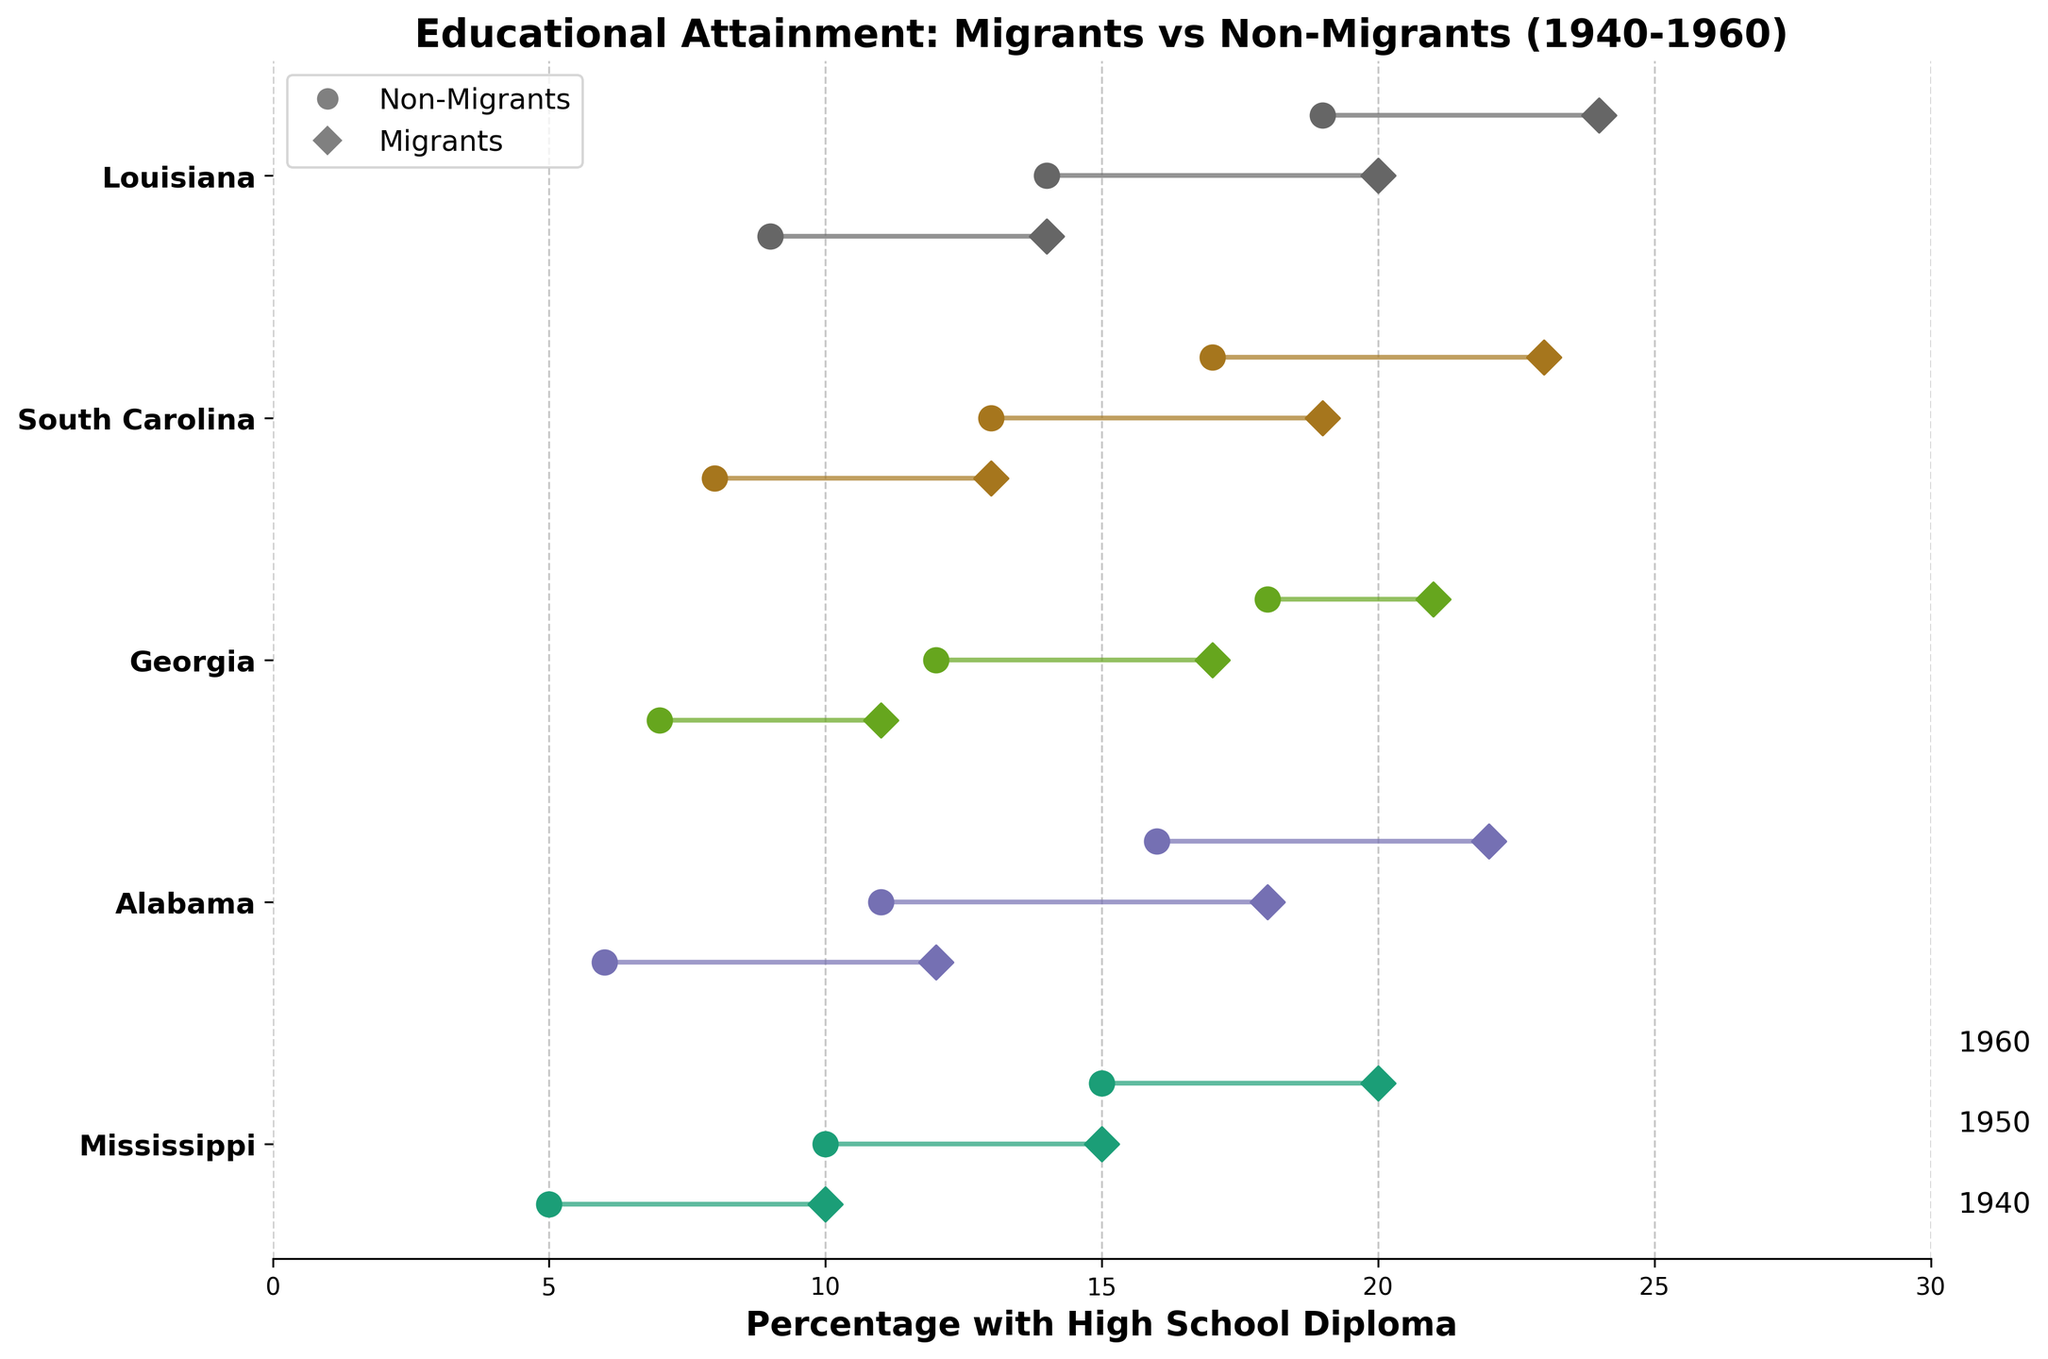How many states are represented in the plot? The plot has separate lines and markers for each state. By counting the distinct labels on the y-axis, we can determine the number of states.
Answer: 5 What trend is observed in the percentage of migrants with a high school diploma from 1940 to 1960? For each state, the plot shows an increasing trend in the percentage of migrants with a high school diploma over the years. This can be observed by the position of the markers which move to higher values from 1940 to 1960.
Answer: Increasing Which state had the highest percentage of non-migrants with a high school diploma in 1960? By locating the 1960 markers for non-migrants across all states, we can compare their values. Louisiana shows the highest percentage with 19%.
Answer: Louisiana How does the percentage gap between migrants and non-migrants with a high school diploma change in Alabama from 1940 to 1960? By examining Alabama specifically, the gap in 1940 is 6% (12%-6%). In 1950, the gap is 7% (18%-11%) and in 1960, it remains 6% (22%-16%).
Answer: The gap increases then remains constant What was the percentage of migrants with a high school diploma in Mississippi in 1950? By identifying the relevant marker for Mississippi in 1950, we see the percentage marked as 15%.
Answer: 15% Which state had the smallest difference between migrants and non-migrants in 1950? By comparing the differences shown for each state in 1950, Georgia had the smallest difference of 5% (17%-12%).
Answer: Georgia In which year did South Carolina have the highest percentage of non-migrants with high school diplomas? By checking the relevant markers for 1940, 1950, and 1960 in South Carolina, the highest percentage for non-migrants is in 1960 with 17%.
Answer: 1960 Comparing 1940 data, which state had the largest difference between migrants and non-migrants with high school diplomas? By observing the differences for each state in 1940, Louisiana had the largest difference with 5% (14% for migrants and 9% for non-migrants).
Answer: Louisiana 